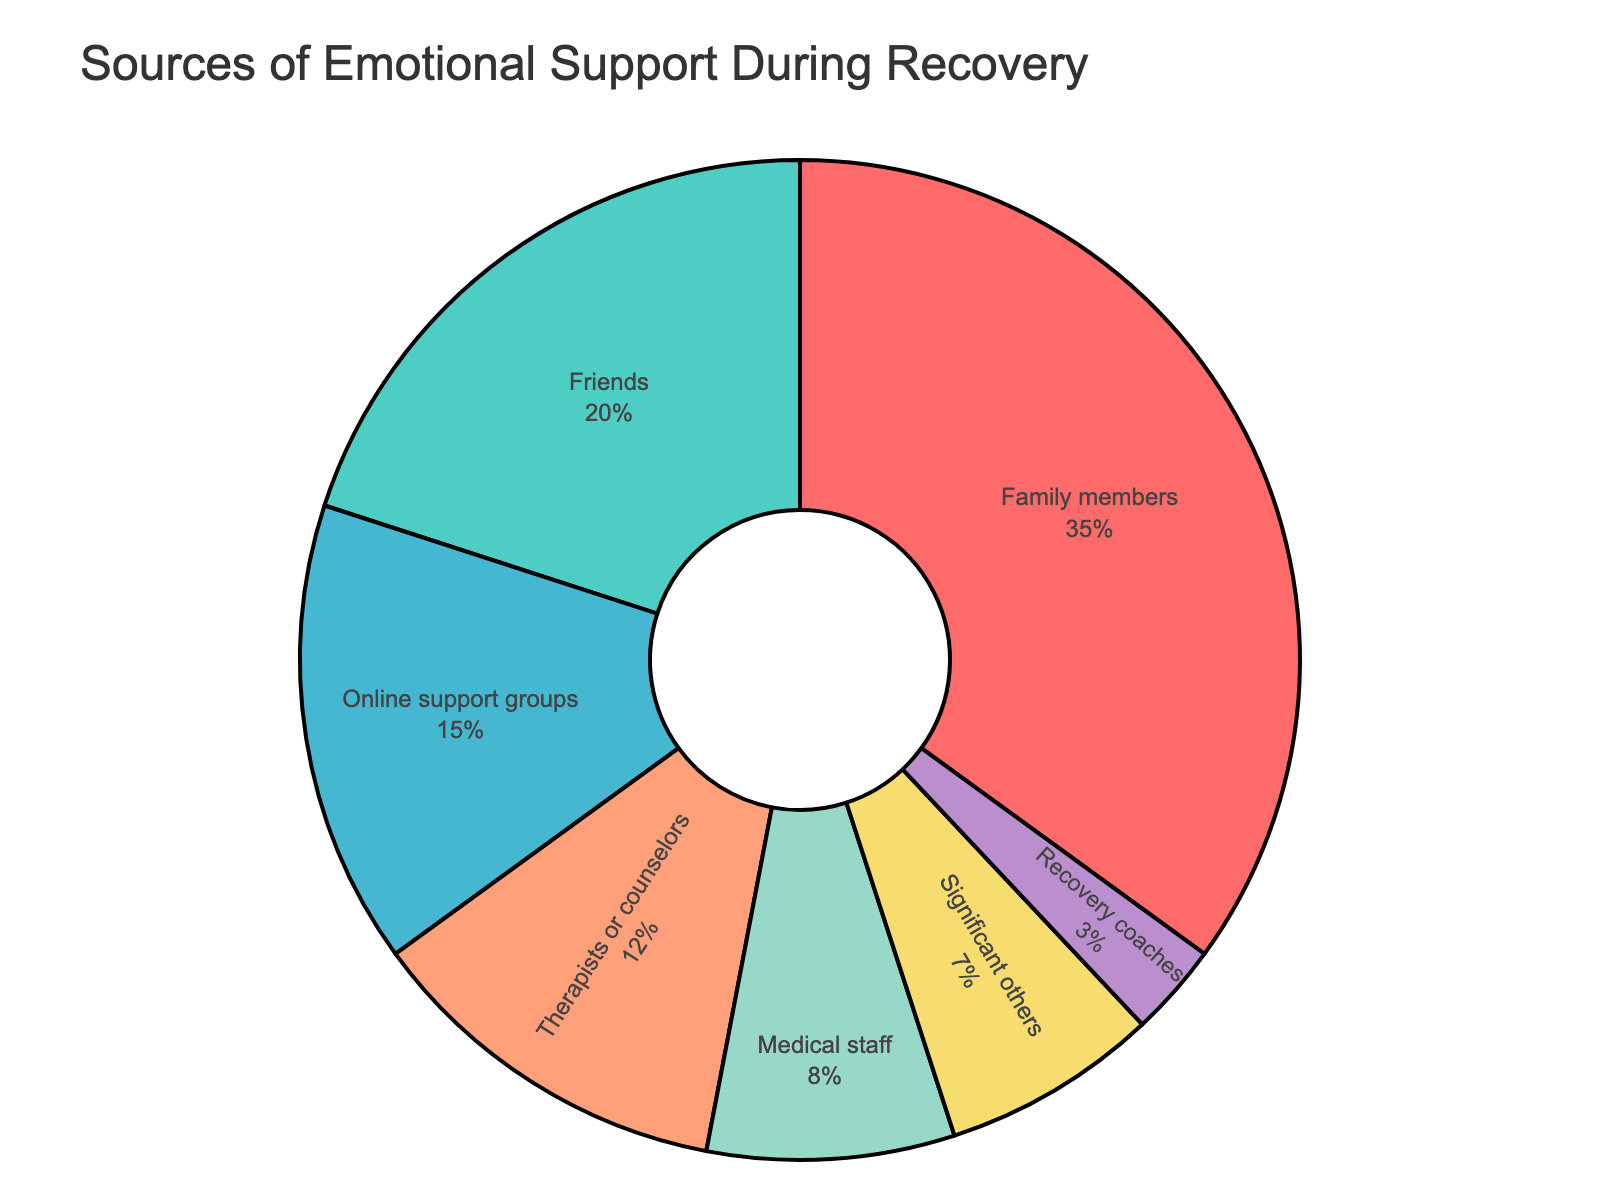What source of emotional support makes up the largest percentage? The segment of the pie chart representing "Family members" is the largest, indicating it provides the highest percentage of emotional support.
Answer: Family members Which source offers more emotional support, friends or therapists? The percentages for friends (20%) and therapists (12%) are compared; friends offer more support.
Answer: Friends What's the combined percentage of support provided by family members and friends? The percentages of family members (35%) and friends (20%) are added together: 35% + 20% = 55%.
Answer: 55% By how much does the support from medical staff differ from that of significant others? Comparing the percentages: medical staff (8%) and significant others (7%): 8% - 7% = 1%.
Answer: 1% Which source provides the least amount of support, and what is its percentage? The smallest segment of the pie chart is "Recovery coaches," which provides 3% of the support.
Answer: Recovery coaches (3%) What's the total percentage of support from online support groups and therapists? The percentages for online support groups (15%) and therapists (12%) are summed: 15% + 12% = 27%.
Answer: 27% Compare the support percentages of significant others and recovery coaches. The chart shows that significant others (7%) provide more support than recovery coaches (3%).
Answer: Significant others What is the sum of the support percentages from medical staff, significant others, and recovery coaches? Adding their percentages: medical staff (8%), significant others (7%), and recovery coaches (3%): 8% + 7% + 3% = 18%.
Answer: 18% How does the percentage of support from online support groups compare to that from therapists? Online support groups provide 15%, whereas therapists provide 12%; thus, online support groups offer more support.
Answer: Online support groups Is the percentage of support from friends greater than the combined support from medical staff and significant others? Adding medical staff (8%) and significant others (7%): 8% + 7% = 15%, which is less than friends (20%).
Answer: Yes 